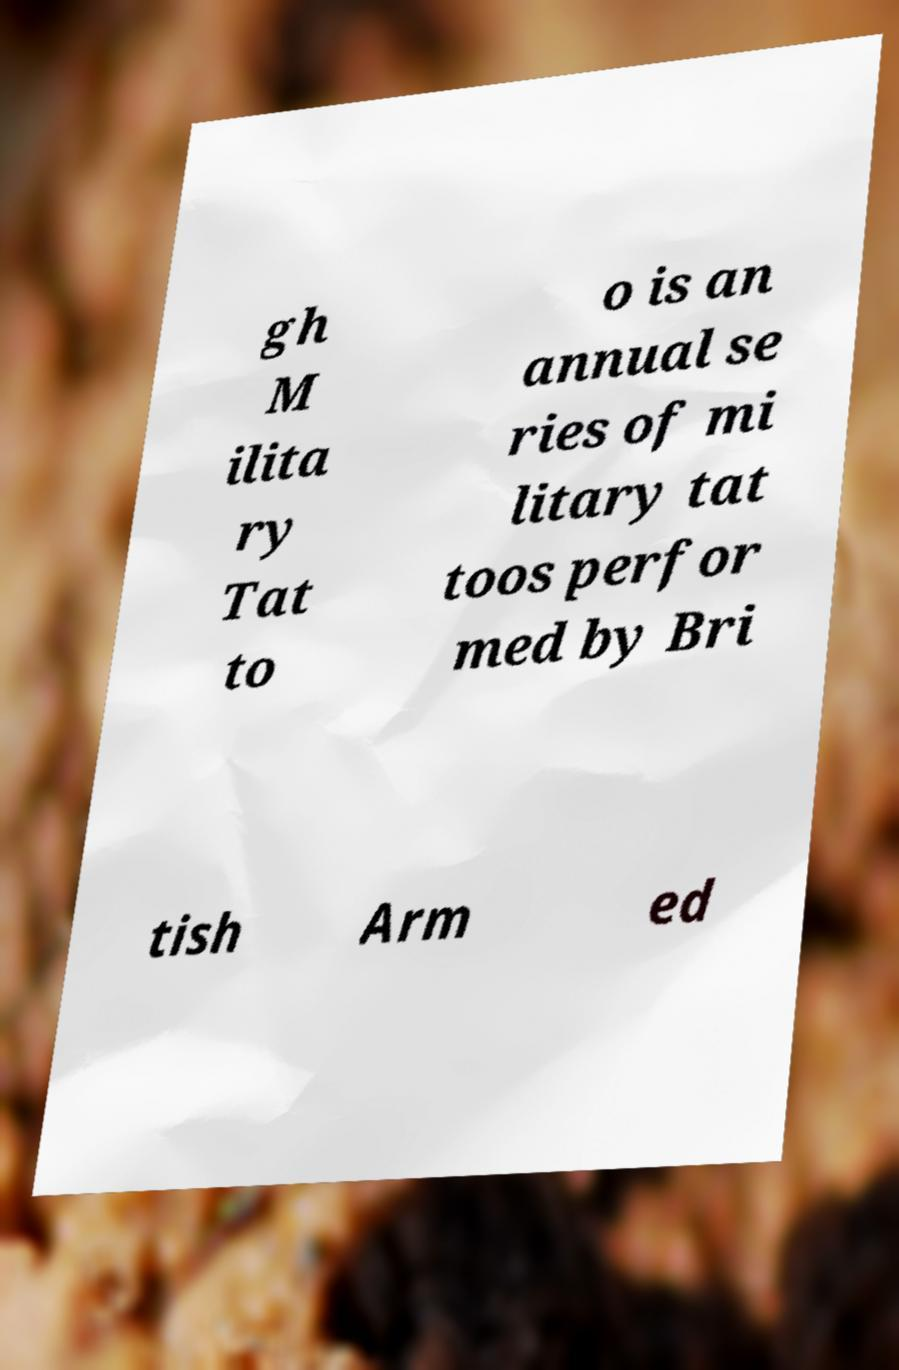There's text embedded in this image that I need extracted. Can you transcribe it verbatim? gh M ilita ry Tat to o is an annual se ries of mi litary tat toos perfor med by Bri tish Arm ed 